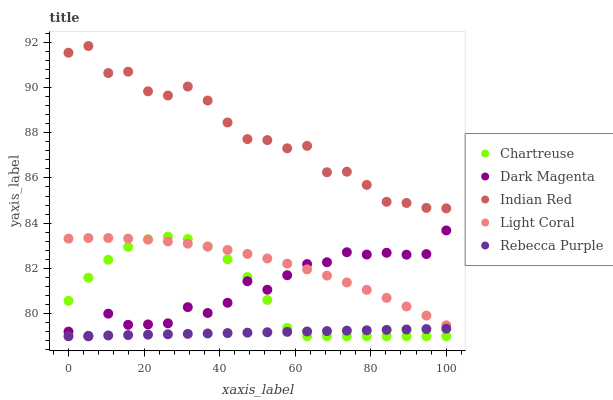Does Rebecca Purple have the minimum area under the curve?
Answer yes or no. Yes. Does Indian Red have the maximum area under the curve?
Answer yes or no. Yes. Does Chartreuse have the minimum area under the curve?
Answer yes or no. No. Does Chartreuse have the maximum area under the curve?
Answer yes or no. No. Is Rebecca Purple the smoothest?
Answer yes or no. Yes. Is Indian Red the roughest?
Answer yes or no. Yes. Is Chartreuse the smoothest?
Answer yes or no. No. Is Chartreuse the roughest?
Answer yes or no. No. Does Chartreuse have the lowest value?
Answer yes or no. Yes. Does Indian Red have the lowest value?
Answer yes or no. No. Does Indian Red have the highest value?
Answer yes or no. Yes. Does Chartreuse have the highest value?
Answer yes or no. No. Is Light Coral less than Indian Red?
Answer yes or no. Yes. Is Indian Red greater than Rebecca Purple?
Answer yes or no. Yes. Does Dark Magenta intersect Chartreuse?
Answer yes or no. Yes. Is Dark Magenta less than Chartreuse?
Answer yes or no. No. Is Dark Magenta greater than Chartreuse?
Answer yes or no. No. Does Light Coral intersect Indian Red?
Answer yes or no. No. 